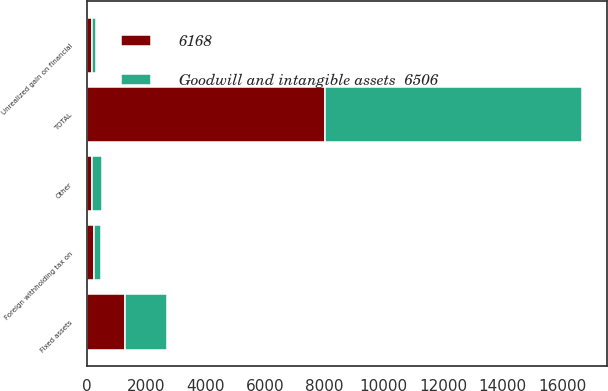<chart> <loc_0><loc_0><loc_500><loc_500><stacked_bar_chart><ecel><fcel>Fixed assets<fcel>Foreign withholding tax on<fcel>Unrealized gain on financial<fcel>Other<fcel>TOTAL<nl><fcel>Goodwill and intangible assets  6506<fcel>1413<fcel>239<fcel>147<fcel>351<fcel>8656<nl><fcel>6168<fcel>1276<fcel>244<fcel>169<fcel>161<fcel>8018<nl></chart> 